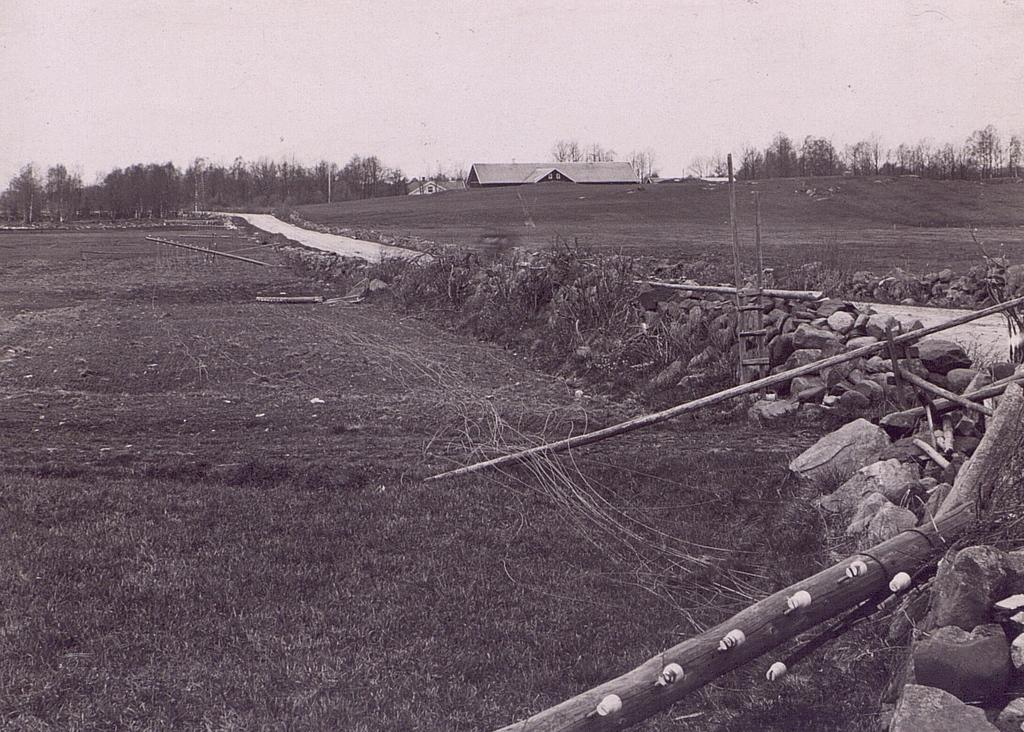What type of landscape is depicted in the image? The image features farmland. What can be seen on the right side of the image? There are plants, stones, and wood on the right side of the image. What is visible in the background of the image? There is a building and many trees in the background of the image. What is visible at the top of the image? The sky is visible at the top of the image. What color of paint is being used by the pet in the image? There is no pet or paint present in the image. How does the spoon affect the plants on the right side of the image? There is no spoon present in the image, so it cannot affect the plants. 